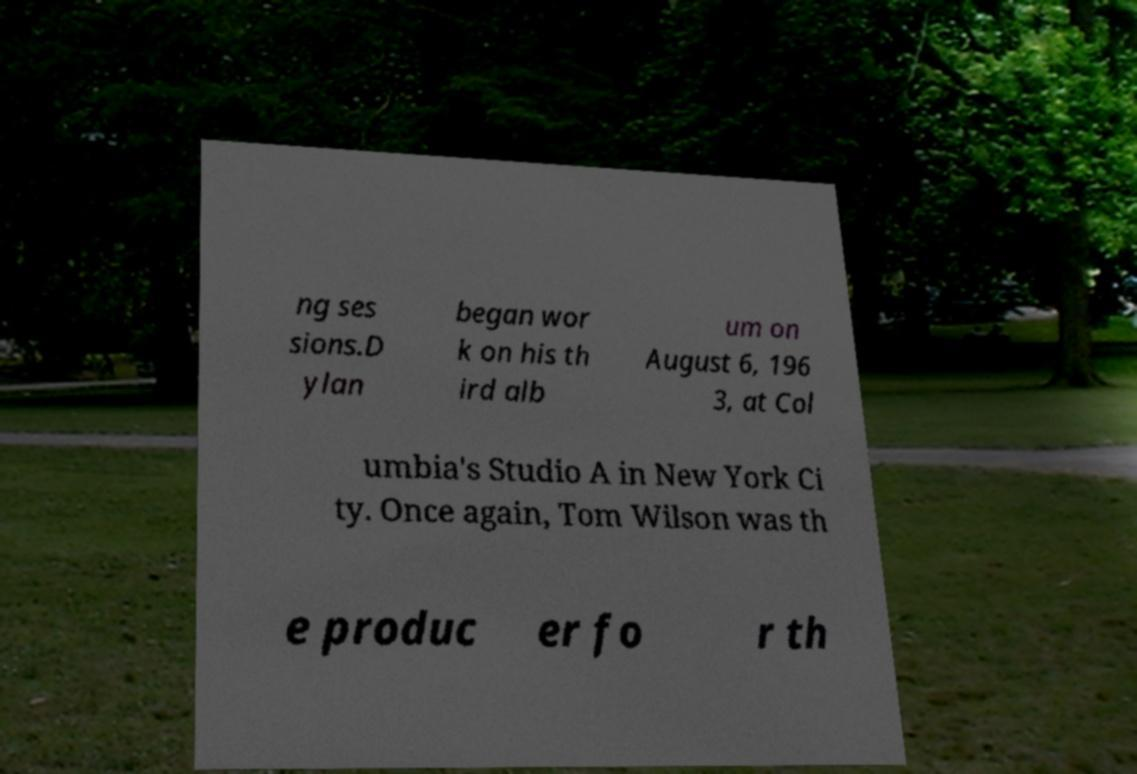For documentation purposes, I need the text within this image transcribed. Could you provide that? ng ses sions.D ylan began wor k on his th ird alb um on August 6, 196 3, at Col umbia's Studio A in New York Ci ty. Once again, Tom Wilson was th e produc er fo r th 